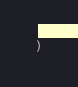Convert code to text. <code><loc_0><loc_0><loc_500><loc_500><_TypeScript_>)
</code> 